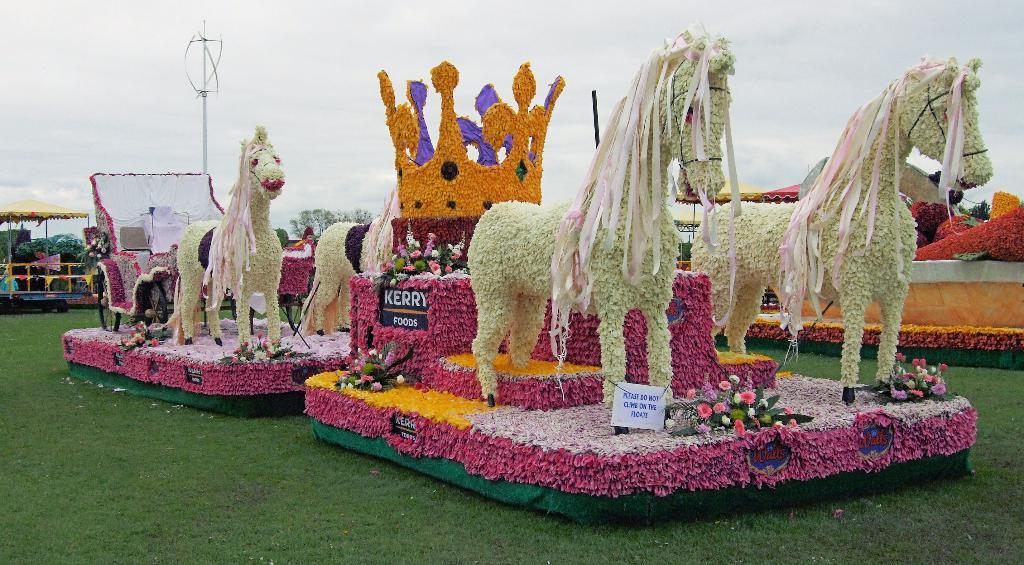What type of decoration can be seen in the image? There is a flower decoration in the image. What elements are included in the decoration? The decoration includes horses, a crown, and a cart. Where is the decoration located in the image? The decoration is placed on the ground. What can be seen in the background of the image? There are trees, tents, and a cloudy sky visible in the background of the image. How many bikes are attached to the branch in the image? There is no branch or bikes present in the image. 